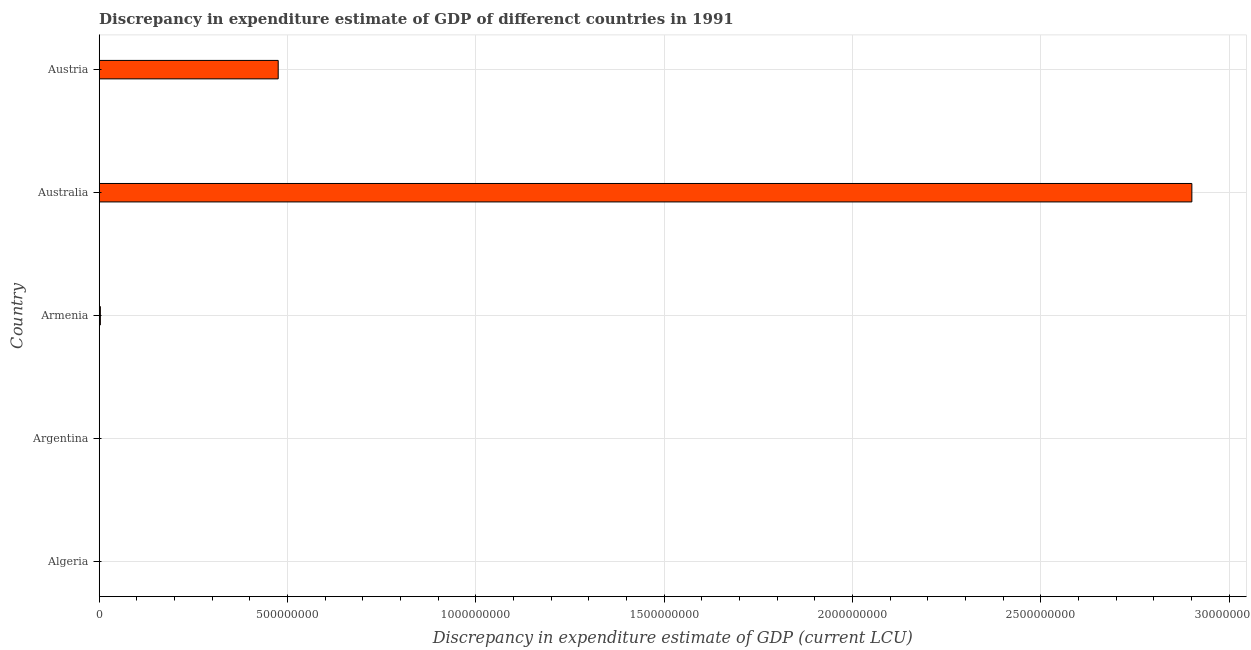Does the graph contain any zero values?
Keep it short and to the point. Yes. Does the graph contain grids?
Ensure brevity in your answer.  Yes. What is the title of the graph?
Make the answer very short. Discrepancy in expenditure estimate of GDP of differenct countries in 1991. What is the label or title of the X-axis?
Your response must be concise. Discrepancy in expenditure estimate of GDP (current LCU). What is the label or title of the Y-axis?
Give a very brief answer. Country. What is the discrepancy in expenditure estimate of gdp in Argentina?
Offer a very short reply. 5100. Across all countries, what is the maximum discrepancy in expenditure estimate of gdp?
Offer a very short reply. 2.90e+09. Across all countries, what is the minimum discrepancy in expenditure estimate of gdp?
Make the answer very short. 0. In which country was the discrepancy in expenditure estimate of gdp maximum?
Your response must be concise. Australia. What is the sum of the discrepancy in expenditure estimate of gdp?
Make the answer very short. 3.38e+09. What is the difference between the discrepancy in expenditure estimate of gdp in Armenia and Australia?
Keep it short and to the point. -2.90e+09. What is the average discrepancy in expenditure estimate of gdp per country?
Ensure brevity in your answer.  6.76e+08. What is the median discrepancy in expenditure estimate of gdp?
Provide a succinct answer. 3.03e+06. What is the difference between the highest and the second highest discrepancy in expenditure estimate of gdp?
Offer a very short reply. 2.43e+09. What is the difference between the highest and the lowest discrepancy in expenditure estimate of gdp?
Offer a very short reply. 2.90e+09. Are all the bars in the graph horizontal?
Make the answer very short. Yes. How many countries are there in the graph?
Provide a succinct answer. 5. Are the values on the major ticks of X-axis written in scientific E-notation?
Provide a succinct answer. No. What is the Discrepancy in expenditure estimate of GDP (current LCU) of Algeria?
Give a very brief answer. 0. What is the Discrepancy in expenditure estimate of GDP (current LCU) of Argentina?
Provide a succinct answer. 5100. What is the Discrepancy in expenditure estimate of GDP (current LCU) in Armenia?
Provide a succinct answer. 3.03e+06. What is the Discrepancy in expenditure estimate of GDP (current LCU) of Australia?
Offer a terse response. 2.90e+09. What is the Discrepancy in expenditure estimate of GDP (current LCU) of Austria?
Offer a terse response. 4.75e+08. What is the difference between the Discrepancy in expenditure estimate of GDP (current LCU) in Argentina and Armenia?
Your response must be concise. -3.02e+06. What is the difference between the Discrepancy in expenditure estimate of GDP (current LCU) in Argentina and Australia?
Keep it short and to the point. -2.90e+09. What is the difference between the Discrepancy in expenditure estimate of GDP (current LCU) in Argentina and Austria?
Your response must be concise. -4.75e+08. What is the difference between the Discrepancy in expenditure estimate of GDP (current LCU) in Armenia and Australia?
Offer a terse response. -2.90e+09. What is the difference between the Discrepancy in expenditure estimate of GDP (current LCU) in Armenia and Austria?
Keep it short and to the point. -4.72e+08. What is the difference between the Discrepancy in expenditure estimate of GDP (current LCU) in Australia and Austria?
Make the answer very short. 2.43e+09. What is the ratio of the Discrepancy in expenditure estimate of GDP (current LCU) in Argentina to that in Armenia?
Make the answer very short. 0. What is the ratio of the Discrepancy in expenditure estimate of GDP (current LCU) in Argentina to that in Australia?
Your answer should be very brief. 0. What is the ratio of the Discrepancy in expenditure estimate of GDP (current LCU) in Armenia to that in Austria?
Offer a terse response. 0.01. What is the ratio of the Discrepancy in expenditure estimate of GDP (current LCU) in Australia to that in Austria?
Your answer should be compact. 6.1. 